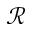Convert formula to latex. <formula><loc_0><loc_0><loc_500><loc_500>\mathcal { R }</formula> 